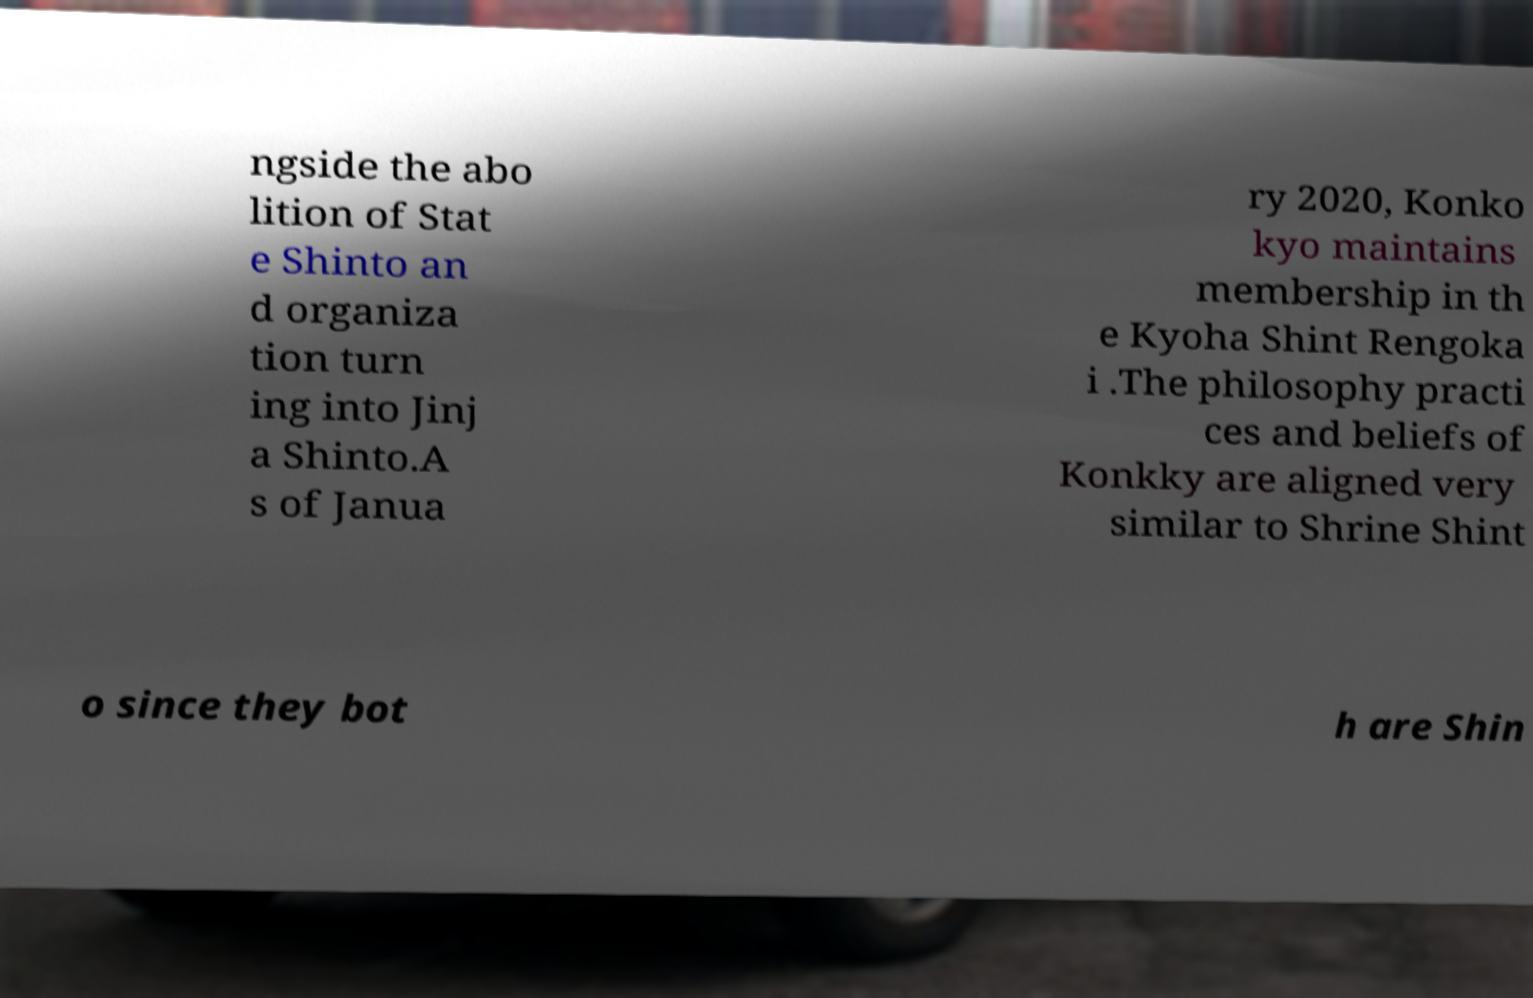Could you assist in decoding the text presented in this image and type it out clearly? ngside the abo lition of Stat e Shinto an d organiza tion turn ing into Jinj a Shinto.A s of Janua ry 2020, Konko kyo maintains membership in th e Kyoha Shint Rengoka i .The philosophy practi ces and beliefs of Konkky are aligned very similar to Shrine Shint o since they bot h are Shin 